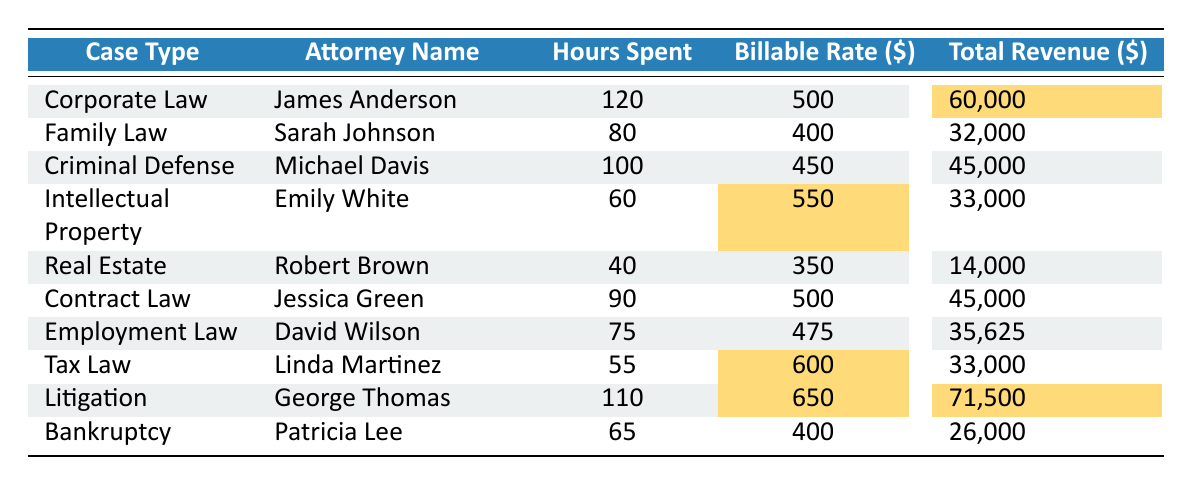What is the total revenue generated by James Anderson in Corporate Law? The table indicates that James Anderson worked in Corporate Law and generated a total revenue of 60,000.
Answer: 60,000 Which attorney spent the most hours on their cases? According to the table, James Anderson spent 120 hours, which is the highest compared to other attorneys.
Answer: James Anderson What is the billable rate for David Wilson in Employment Law? The table shows that David Wilson has a billable rate of 475 for Employment Law.
Answer: 475 How much total revenue was generated in Litigation? From the table, George Thomas generated a total revenue of 71,500 from Litigation.
Answer: 71,500 What is the average billable rate of all attorneys listed in the table? To find the average, sum the billable rates: (500 + 400 + 450 + 550 + 350 + 500 + 475 + 600 + 650 + 400) = 4750, and divide by the number of attorneys (10), which gives an average of 475.
Answer: 475 Is Emily White's total revenue greater than 30,000? The table states that Emily White's total revenue is 33,000, which is indeed greater than 30,000.
Answer: Yes Which case type has the highest total revenue, and what is that amount? By reviewing the total revenues, Litigation has the highest total revenue of 71,500.
Answer: Litigation, 71,500 What is the minimum number of hours spent by an attorney in the cases listed? Looking at the table, Robert Brown spent the least time at 40 hours in Real Estate.
Answer: 40 How much more total revenue was generated by James Anderson than Sarah Johnson? James Anderson's total revenue is 60,000 and Sarah Johnson's is 32,000. The difference is 60,000 - 32,000 = 28,000.
Answer: 28,000 If you combine the hours spent by the attorneys in Tax Law and Bankruptcy, how many hours is that? Tax Law has 55 hours (Linda Martinez) and Bankruptcy has 65 hours (Patricia Lee). Adding them together: 55 + 65 = 120.
Answer: 120 